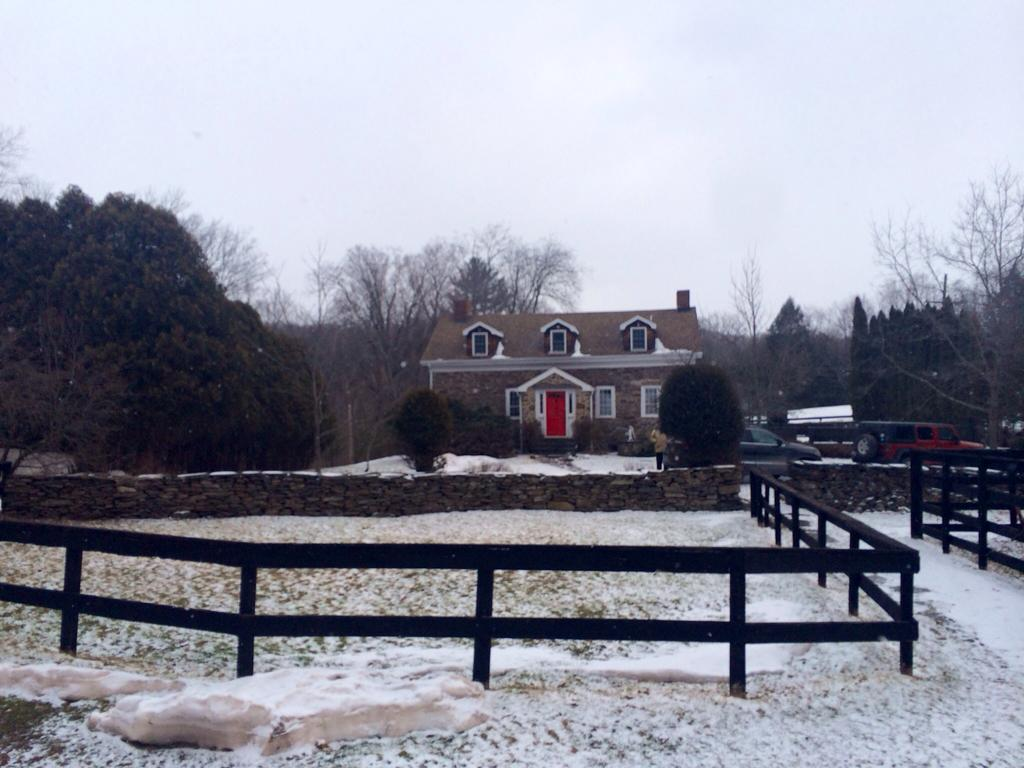What type of structure is visible in the image? There is a building in the image. What natural elements can be seen in the image? There are trees and plants visible in the image. What type of barrier is present at the bottom of the image? There is wooden fencing at the bottom of the image. What is visible at the top of the image? The sky is visible at the top of the image. What atmospheric feature can be seen in the sky? Clouds are present in the sky. How does the building twist in the image? The building does not twist in the image; it is a stationary structure. What type of food is being increased in the image? There is no food or increase of food present in the image. 